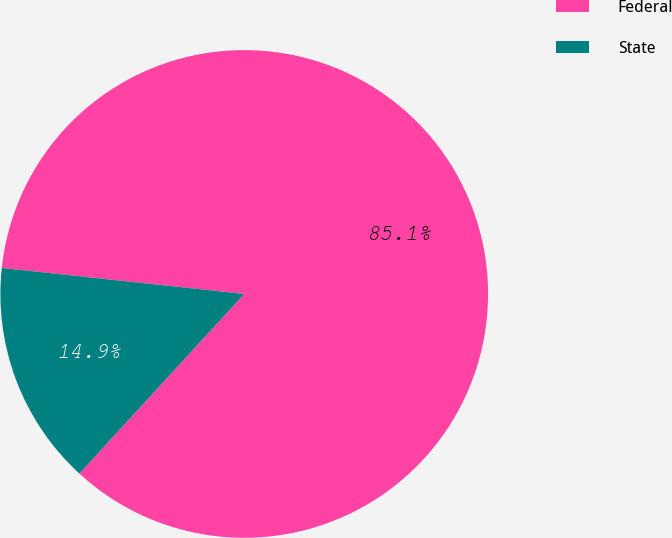Convert chart. <chart><loc_0><loc_0><loc_500><loc_500><pie_chart><fcel>Federal<fcel>State<nl><fcel>85.12%<fcel>14.88%<nl></chart> 